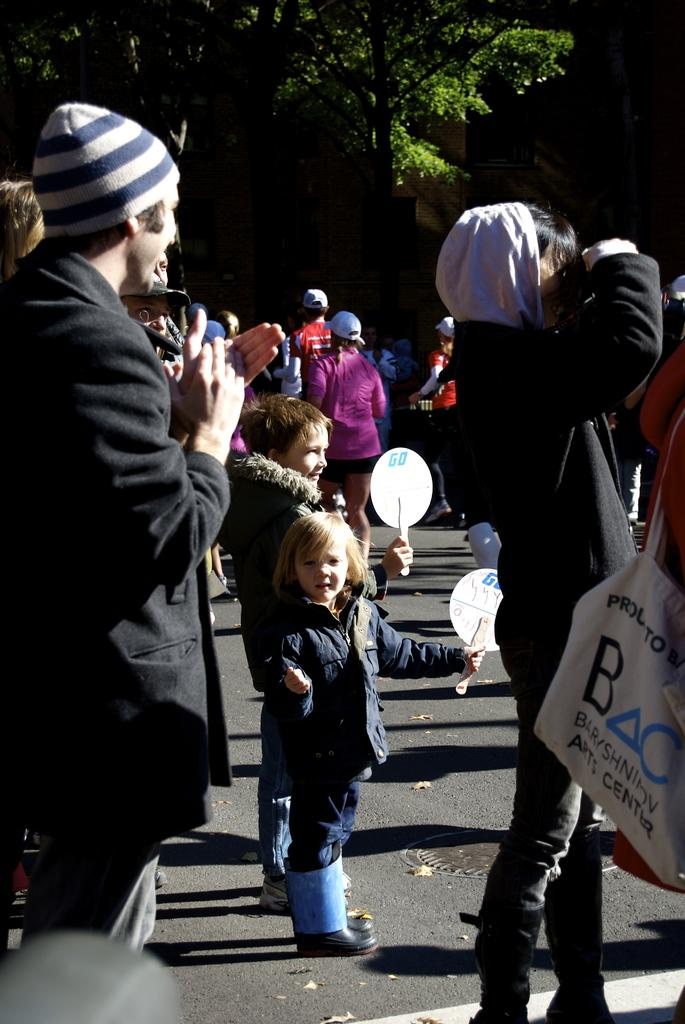What are the people in the image doing? The people in the image are standing on the road. What can be seen in the background behind the people? There are trees visible behind the people. What type of magic trick is the person performing in the image? There is no magic trick or person performing a magic trick in the image. What game are the people playing in the image? There is no game being played in the image; the people are simply standing on the road. 